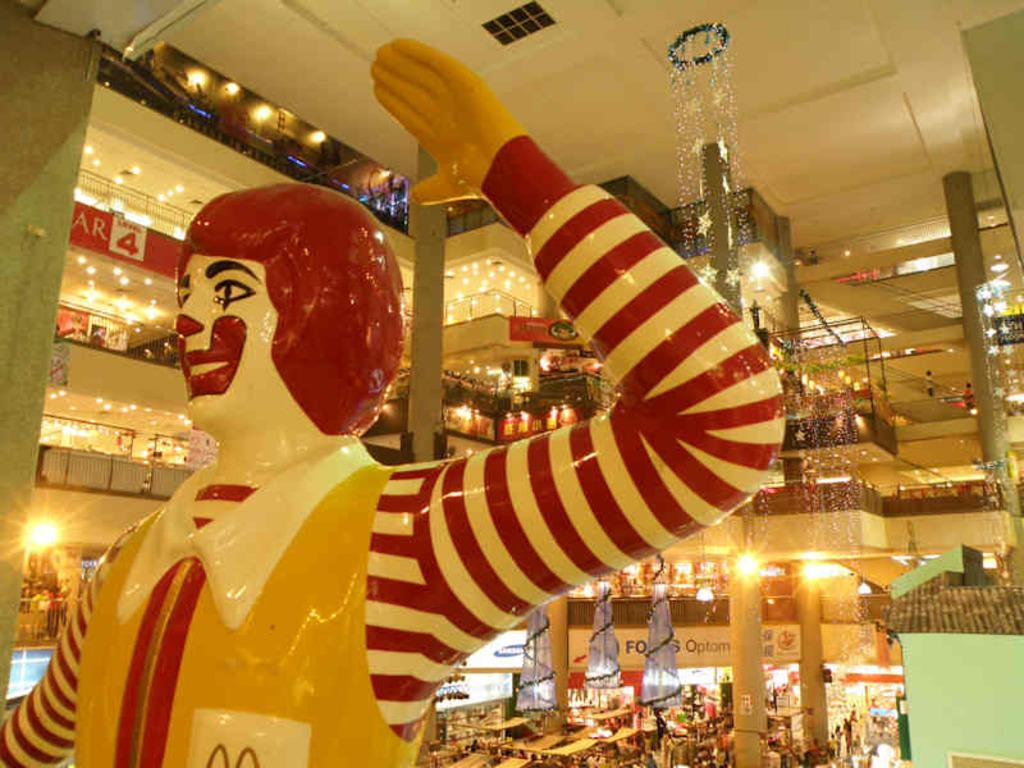What is: What is the main subject in the image? There is a statue in the image. What can be seen in the background of the image? There is a shopping mall in the background of the image. What type of furniture is present in the image? There are tables and chairs in the image. Are there any people in the image? Yes, there are people in the image. What type of advice can be seen being given by the statue in the image? The statue is not giving any advice in the image; it is a stationary object. 